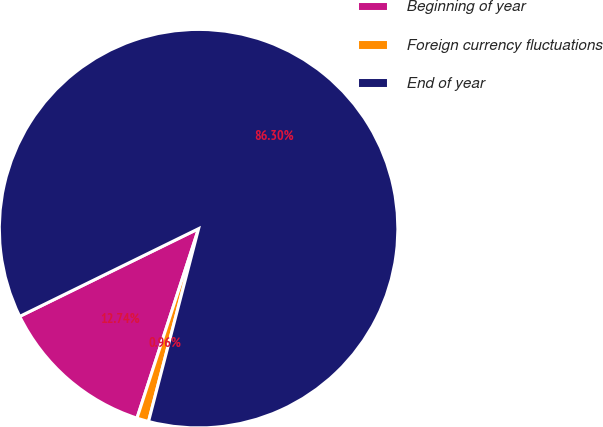Convert chart. <chart><loc_0><loc_0><loc_500><loc_500><pie_chart><fcel>Beginning of year<fcel>Foreign currency fluctuations<fcel>End of year<nl><fcel>12.74%<fcel>0.96%<fcel>86.3%<nl></chart> 